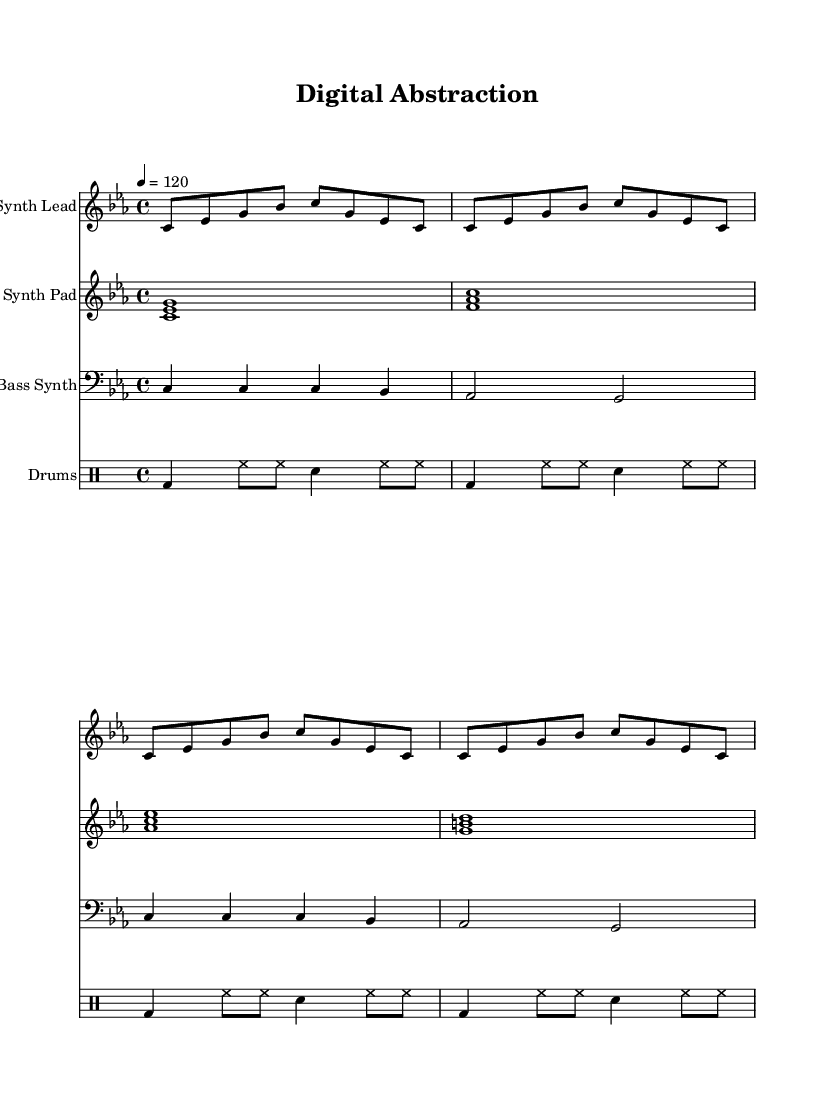What is the key signature of this music? The key signature indicates the use of B flat and E flat, which corresponds to C minor. You can identify the key signature by looking at the beginning of the staff where the sharps or flats are notated.
Answer: C minor What is the time signature of this music? The time signature appears at the beginning of the piece, represented by "4/4". This indicates that there are four beats in each measure and the quarter note gets one beat.
Answer: 4/4 What is the tempo marking in this sheet music? The tempo is indicated as "4 = 120", which means the quarter note should be played at a speed of 120 beats per minute. This information is found near the beginning of the score, setting the pace for the composition.
Answer: 120 How many measures are there in the drum pattern? To find the number of measures, count the groups of beats represented in the drum pattern. Each group that has a full set of beats and is separated by bar lines represents a measure. Here, there are four groups of rhythmic patterns, indicating four measures.
Answer: 4 Which instruments are featured in this score? The score lists different instrument names at the beginning of each staff. They include "Synth Lead," "Synth Pad," "Bass Synth," and "Drums." By reading the titles above each staff, you can identify the instruments used.
Answer: Synth Lead, Synth Pad, Bass Synth, Drums What texture does this piece primarily use? The piece is characterized by layered textures as indicated by the multiple voices of synths and the rhythm provided by drums, which contribute to its experimental electronic pop sound. This can be understood from the presence of different musical lines that combine to create a richer sound.
Answer: Layered textures 